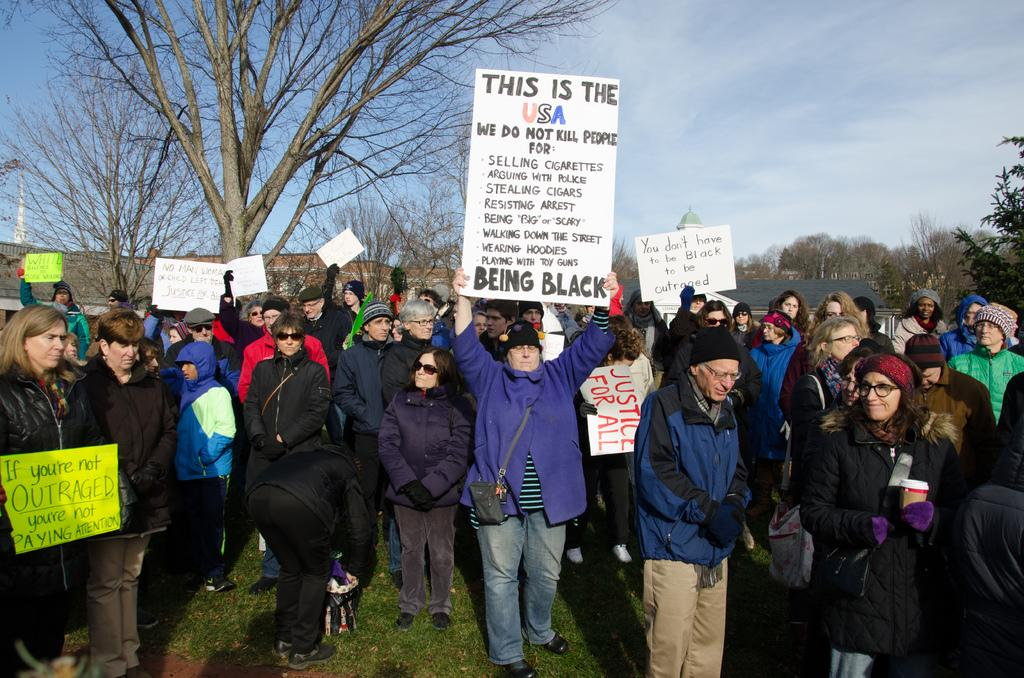What can be seen in the foreground of the picture? There are people in the foreground of the picture. What are the people holding in the picture? The people are holding placards in the picture. What is located in the middle of the picture? There are trees and buildings in the middle of the picture. What is visible at the top of the picture? The sky is visible at the top of the picture. How many sheep can be seen grazing in the middle of the picture? There are no sheep present in the image; it features trees and buildings. What type of curve is visible in the sky in the picture? There is no curve visible in the sky in the picture; the sky is visible at the top of the image without any specific features mentioned. 